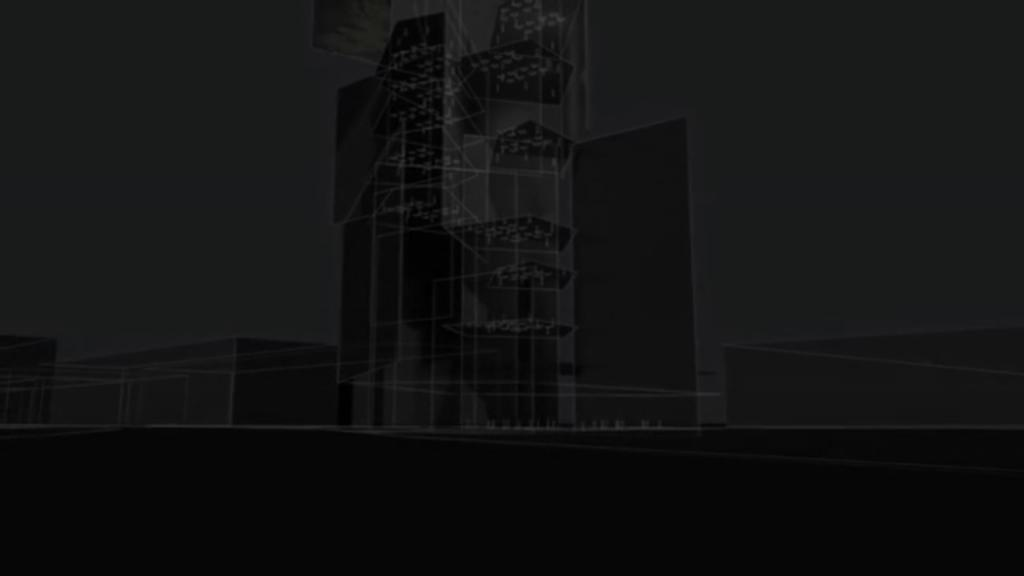What type of structures are present in the image? There are buildings in the image. How are the buildings depicted? The buildings have a graphical effect. Can you describe the overall appearance of the image? The image appears dark. What type of group activity is taking place in the image? There is no group activity present in the image; it features buildings with a graphical effect in a dark setting. What type of shame can be seen on the buildings in the image? There is no shame present on the buildings in the image; they are depicted with a graphical effect in a dark setting. 